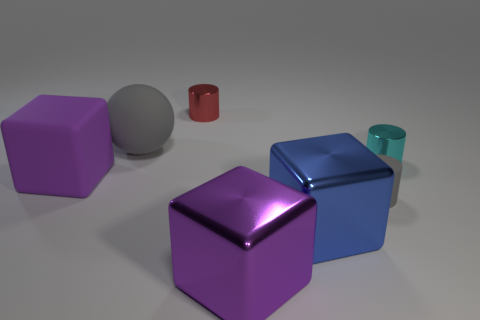Are there fewer tiny red metal cylinders in front of the large purple metal block than big yellow matte balls?
Offer a terse response. No. Is there a rubber object that has the same size as the purple shiny thing?
Ensure brevity in your answer.  Yes. Does the big rubber cube have the same color as the rubber object that is behind the rubber cube?
Provide a succinct answer. No. There is a gray object behind the small cyan cylinder; what number of gray balls are to the left of it?
Your answer should be very brief. 0. The shiny cylinder behind the gray object that is behind the tiny gray cylinder is what color?
Your answer should be very brief. Red. There is a big thing that is both in front of the sphere and behind the big blue object; what is its material?
Your response must be concise. Rubber. Are there any red metal objects that have the same shape as the blue object?
Give a very brief answer. No. There is a big purple thing to the left of the tiny red thing; does it have the same shape as the small gray thing?
Offer a very short reply. No. What number of cylinders are behind the large matte sphere and to the right of the purple metal object?
Give a very brief answer. 0. The big matte object that is in front of the large gray object has what shape?
Provide a short and direct response. Cube. 